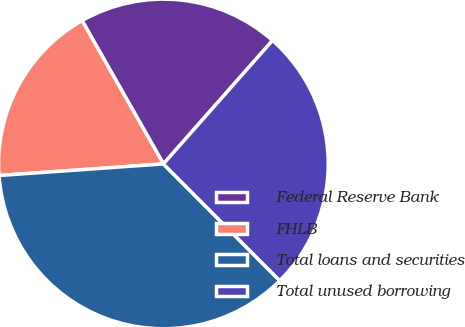Convert chart. <chart><loc_0><loc_0><loc_500><loc_500><pie_chart><fcel>Federal Reserve Bank<fcel>FHLB<fcel>Total loans and securities<fcel>Total unused borrowing<nl><fcel>19.74%<fcel>17.9%<fcel>36.35%<fcel>26.01%<nl></chart> 